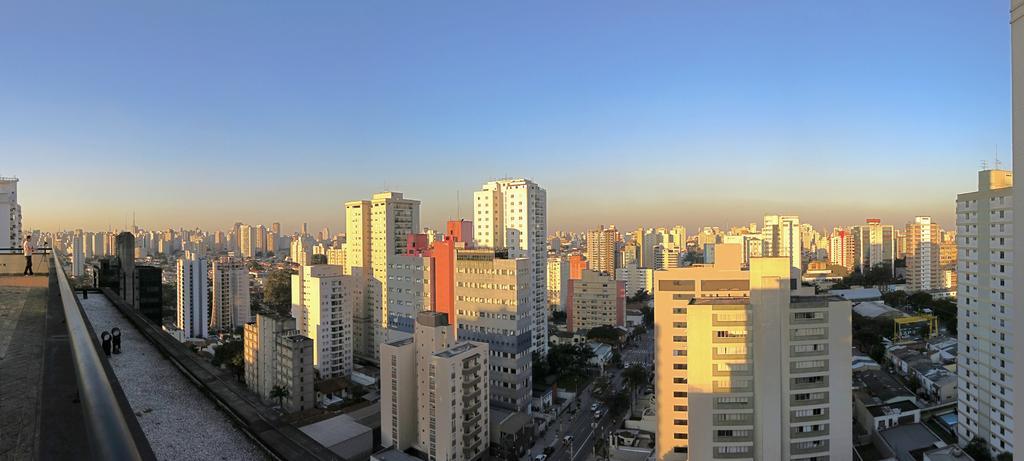In one or two sentences, can you explain what this image depicts? In this image there are many buildings. Here we can see a road. On the road there are ,any vehicles. A person is standing in the left. The sky is clear. 